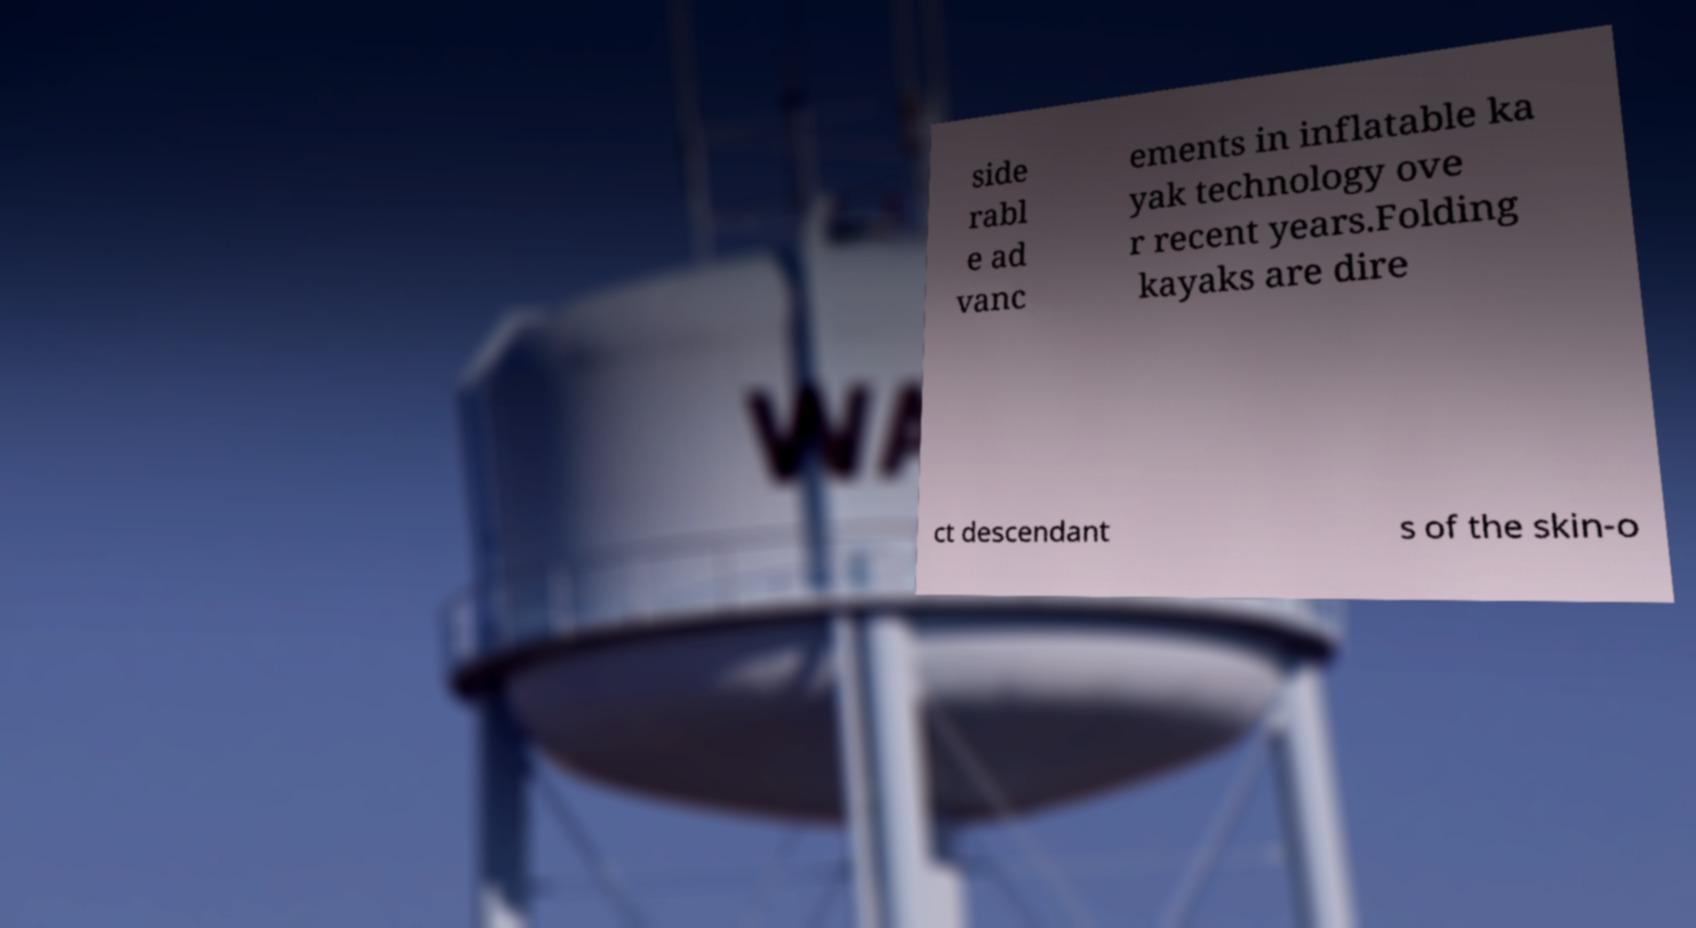Could you assist in decoding the text presented in this image and type it out clearly? side rabl e ad vanc ements in inflatable ka yak technology ove r recent years.Folding kayaks are dire ct descendant s of the skin-o 